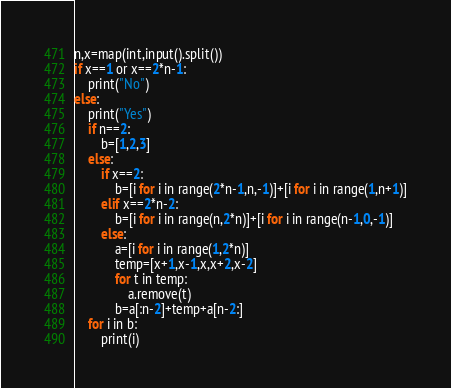<code> <loc_0><loc_0><loc_500><loc_500><_Python_>n,x=map(int,input().split())
if x==1 or x==2*n-1:
    print("No")
else:
    print("Yes")
    if n==2:
        b=[1,2,3]
    else:
        if x==2:
            b=[i for i in range(2*n-1,n,-1)]+[i for i in range(1,n+1)]
        elif x==2*n-2:
            b=[i for i in range(n,2*n)]+[i for i in range(n-1,0,-1)]
        else:
            a=[i for i in range(1,2*n)]
            temp=[x+1,x-1,x,x+2,x-2]
            for t in temp:
                a.remove(t)
            b=a[:n-2]+temp+a[n-2:]
    for i in b:
        print(i)</code> 